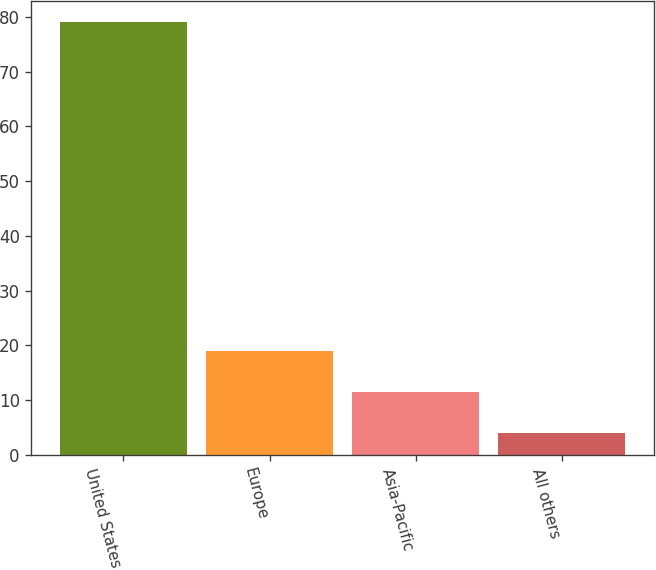Convert chart to OTSL. <chart><loc_0><loc_0><loc_500><loc_500><bar_chart><fcel>United States<fcel>Europe<fcel>Asia-Pacific<fcel>All others<nl><fcel>79<fcel>19<fcel>11.5<fcel>4<nl></chart> 